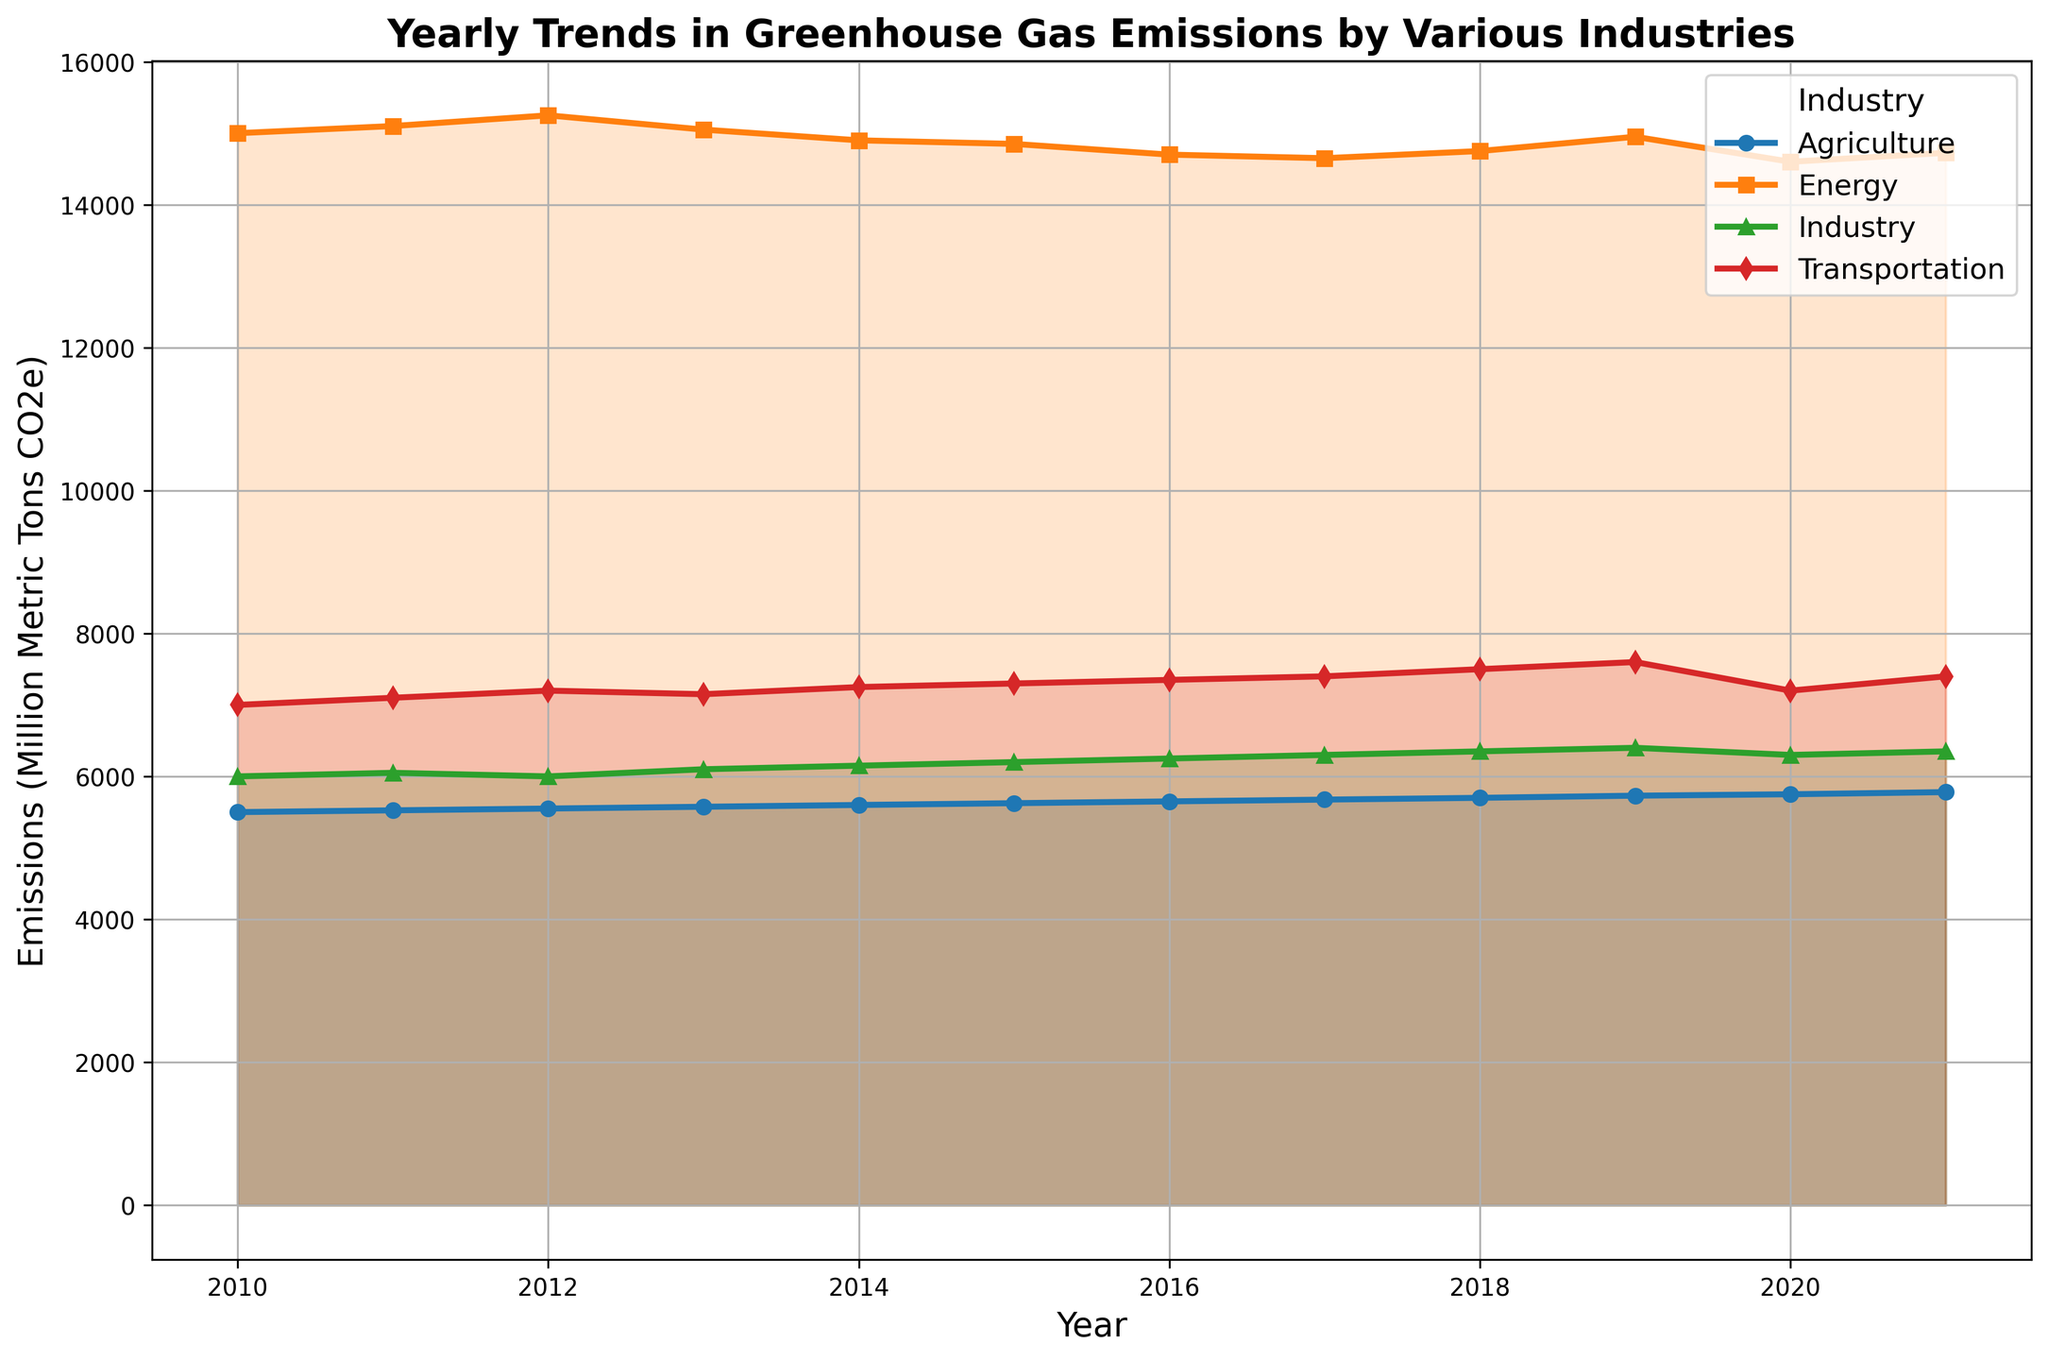What was the general trend in greenhouse gas emissions in the Energy sector between 2010 and 2021? By examining the plot, we see that emissions in the Energy sector started around 15000 million metric tons in 2010, experienced a slight increase until about 2012, then generally declined until 2021 with minor fluctuations.
Answer: Generally declining Which industry had the highest emissions in 2021? Observing the plot, the Energy sector is the highest at about 14725 million metric tons in 2021.
Answer: Energy What was the difference in emissions between the Transportation and Industry sectors in 2020? The plot shows that Transportation had emissions around 7200 million metric tons and Industry had around 6300 million metric tons in 2020. The difference is 7200 - 6300.
Answer: 900 million metric tons Which industry showed the least variation in emissions over the years? By observing the changes in the y-values, Agriculture shows the least variation with small, consistent increments each year from 5500 million metric tons in 2010 to 5780 million metric tons in 2021.
Answer: Agriculture In which year did the Energy sector see its lowest emissions and what were they? From the plot, the Energy sector’s lowest emissions were around 14600 million metric tons in 2020.
Answer: 2020, 14600 million metric tons Compare the trends in the Transportation and Agriculture sectors from 2010 to 2021. The plot shows that both sectors show an overall increasing trend. Transportation has a slight dip around 2020 but then increases again, while Agriculture shows a steady, gradual increase each year.
Answer: Both increasing, Transportation slightly dips around 2020 By how much did emissions in the Industry sector increase from 2010 to 2019? From the plot, Industry emissions were around 6000 in 2010 and around 6400 in 2019, resulting in an increase of 6400 - 6000.
Answer: 400 million metric tons Rank the industries based on their 2021 emissions. Observing the plot, the order from highest to lowest emissions in 2021 is: Energy, Transportation, Industry, Agriculture.
Answer: Energy > Transportation > Industry > Agriculture Calculate the average emissions in the Energy sector over the 12 years. The values for Energy emissions are 15000, 15100, 15250, 15050, 14900, 14850, 14700, 14650, 14750, 14950, 14600, 14725. Sum these and divide by 12: (15000 + 15100 + 15250 + 15050 + 14900 + 14850 + 14700 + 14650 + 14750 + 14950 + 14600 + 14725) / 12 = 14827.5.
Answer: 14827.5 